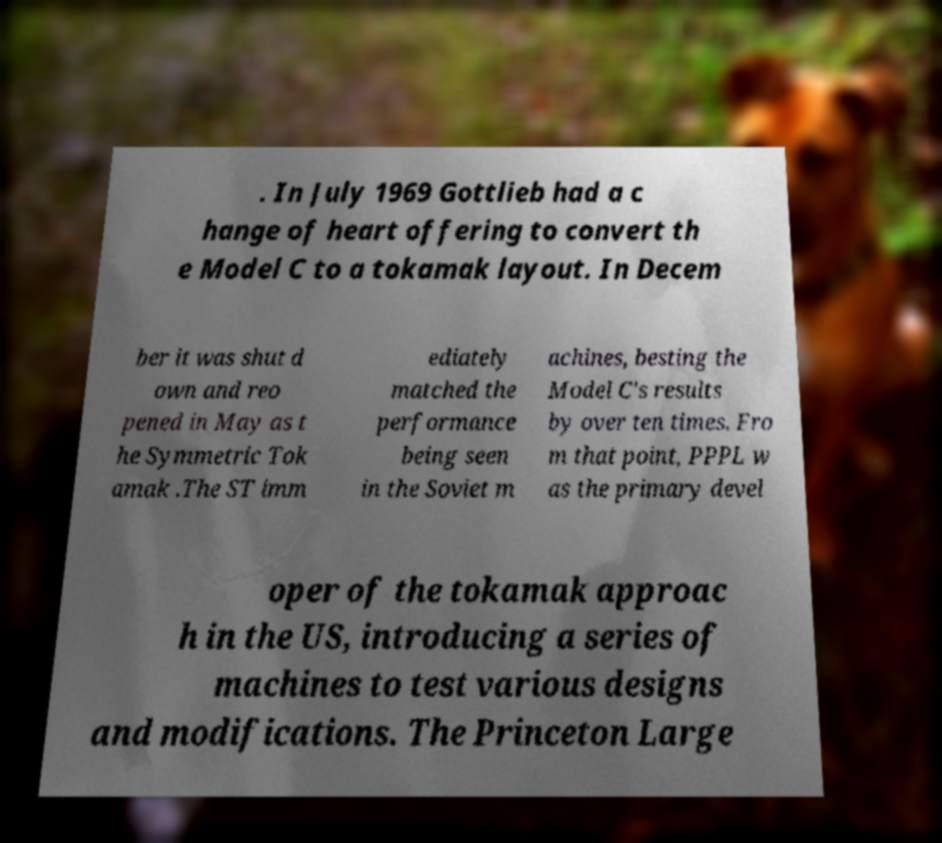I need the written content from this picture converted into text. Can you do that? . In July 1969 Gottlieb had a c hange of heart offering to convert th e Model C to a tokamak layout. In Decem ber it was shut d own and reo pened in May as t he Symmetric Tok amak .The ST imm ediately matched the performance being seen in the Soviet m achines, besting the Model C's results by over ten times. Fro m that point, PPPL w as the primary devel oper of the tokamak approac h in the US, introducing a series of machines to test various designs and modifications. The Princeton Large 